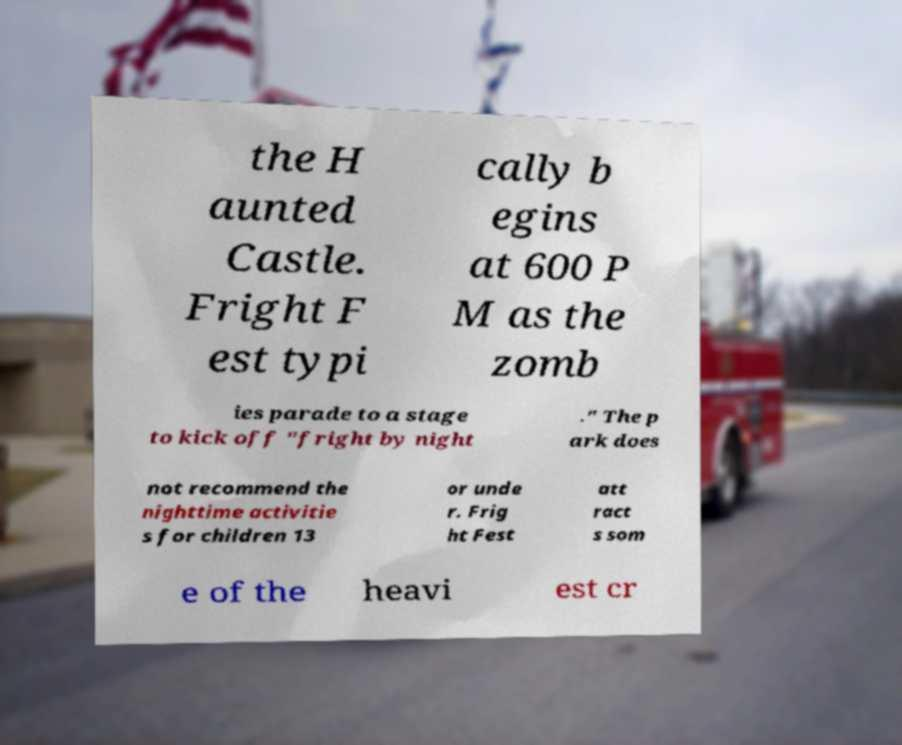Could you extract and type out the text from this image? the H aunted Castle. Fright F est typi cally b egins at 600 P M as the zomb ies parade to a stage to kick off "fright by night ." The p ark does not recommend the nighttime activitie s for children 13 or unde r. Frig ht Fest att ract s som e of the heavi est cr 